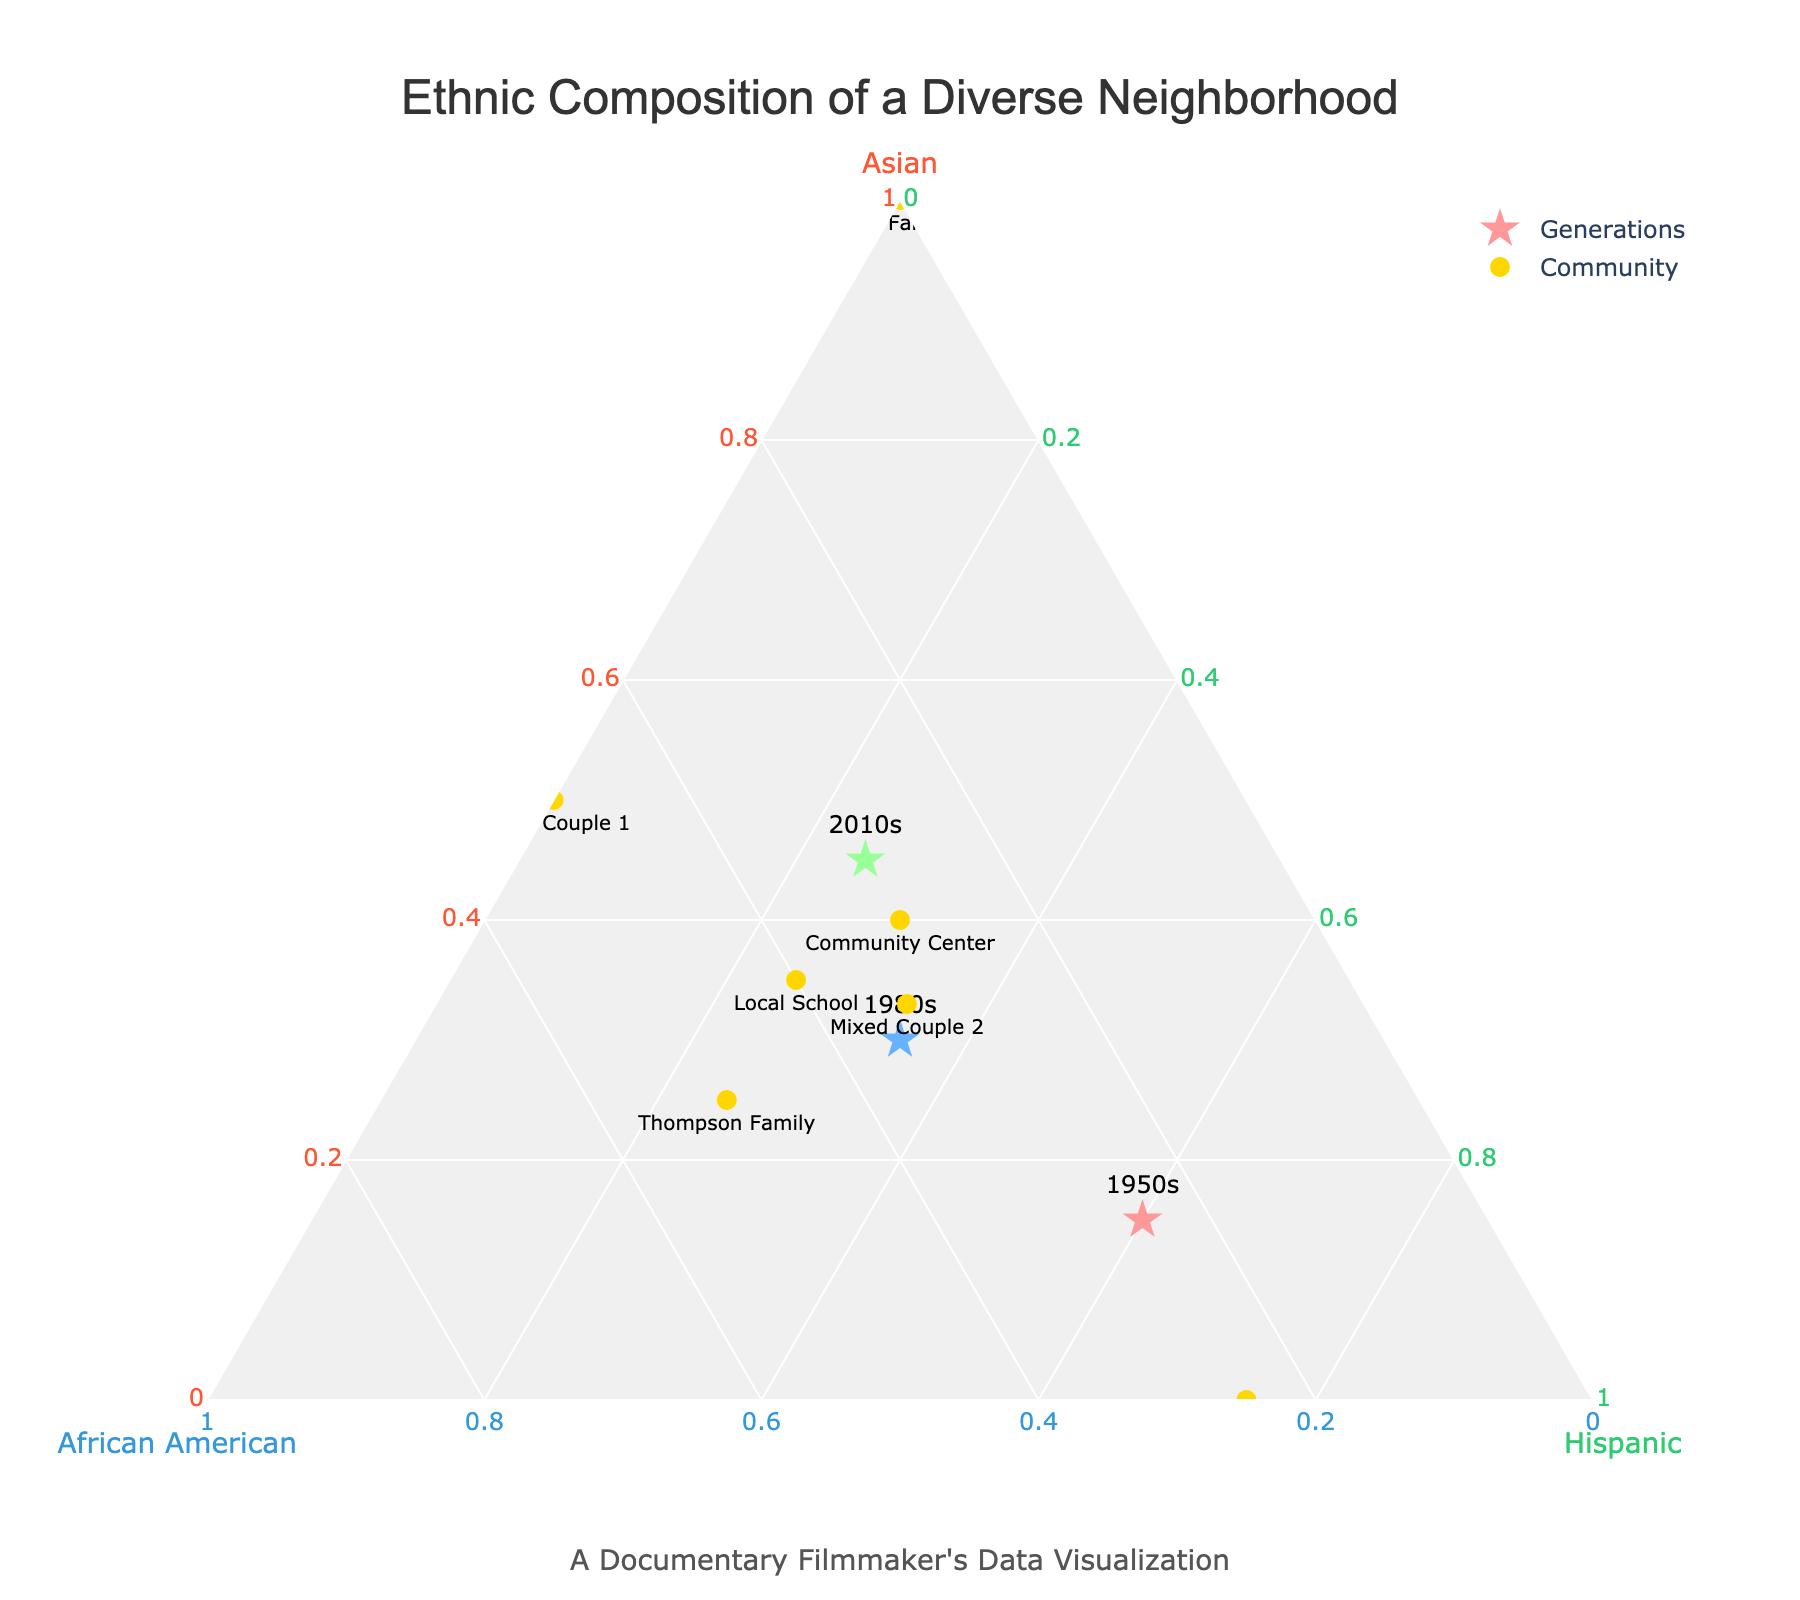What is the title of the figure? The title of the figure is often found at the top of the plot. By examining the figure, we can read the title directly.
Answer: Ethnic Composition of a Diverse Neighborhood How many generations are represented in the figure? The generations are indicated by different symbols in the plot. Looking at these markers and their labels, we identify the distinct generations displayed.
Answer: Three Which family has the highest percentage of Hispanic ethnicity? To determine this, look at the data points for each family and identify the one with the highest value in the Hispanic axis. This often requires reading the labels and values from the plot or legend.
Answer: Rodriguez Family What's the total percentage of Hispanic ethnicity for the 1980s generation? The total percentage for each generation can be read directly from the plot for the specific generation. The sum should always equal 100%, but we can double-check the value shown for the Hispanic axis.
Answer: 35% Which data point is closest to being equally divided among all three ethnicities? This involves examining the positions of the data points in relation to the three axes. The point closest to the center of the plot represents the most even distribution.
Answer: Mixed Couple 2 How has the percentage of Asian ethnicity changed from the 1950s to the 2010s? We need to locate the data points for the 1950s and 2010s generations and compare their positions along the Asian axis. This involves reading both values and calculating the difference.
Answer: Increased from 0.15 to 0.45 Is there any group in the plot defining their ethnicity exclusively as Asian? To identify an exclusive group, we check if there is any data point positioned exactly on the respective axis, indicating 100% for one ethnicity and 0% for the others.
Answer: Lee Family Compare the African American representation in the Community Center to that in the Local School. This requires reading the percentage values for African American ethnicity for both the Community Center and Local School and comparing them.
Answer: Community Center: 30%, Local School: 40% What is the trend of Hispanic ethnicity across the three generations shown in the plot? By examining the data points labeled as generations (1950s, 1980s, 2010s), we can observe the changes in Hispanic values over time. Calculate the differences to determine the trend.
Answer: Decreasing For the 1980s generation, which ethnicity has the highest representation? Identify the point for the 1980s generation and compare the values on the three axes to see which is the greatest.
Answer: Asian and African American 